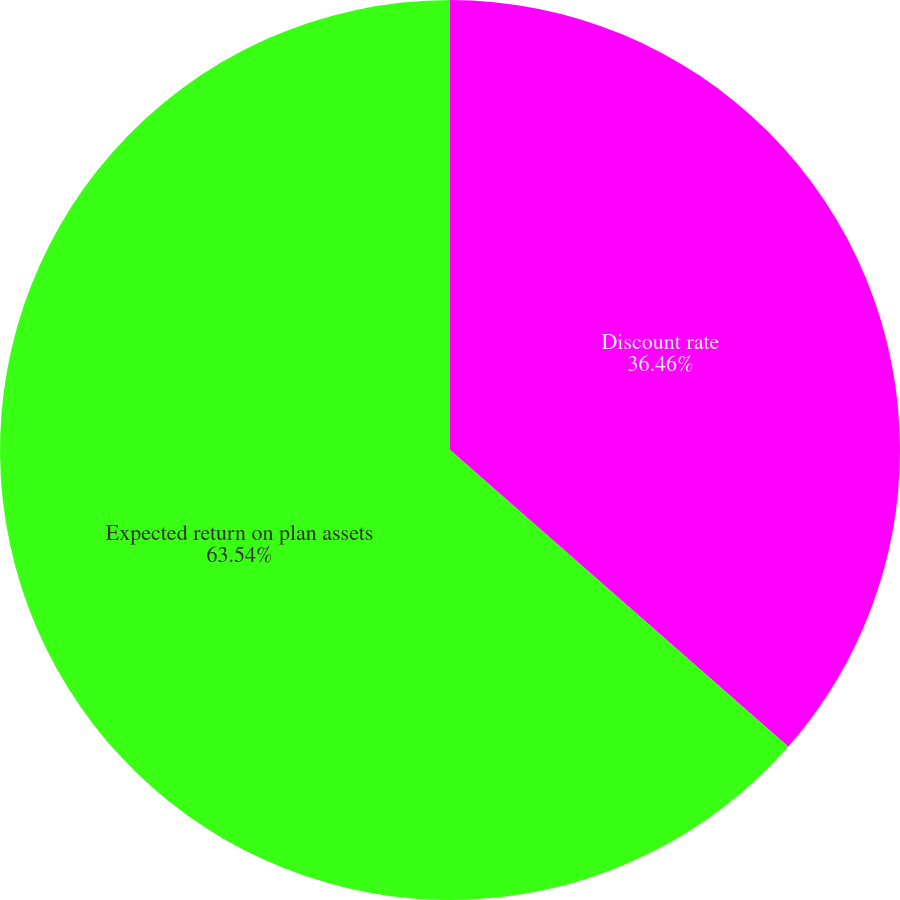Convert chart. <chart><loc_0><loc_0><loc_500><loc_500><pie_chart><fcel>Discount rate<fcel>Expected return on plan assets<nl><fcel>36.46%<fcel>63.54%<nl></chart> 